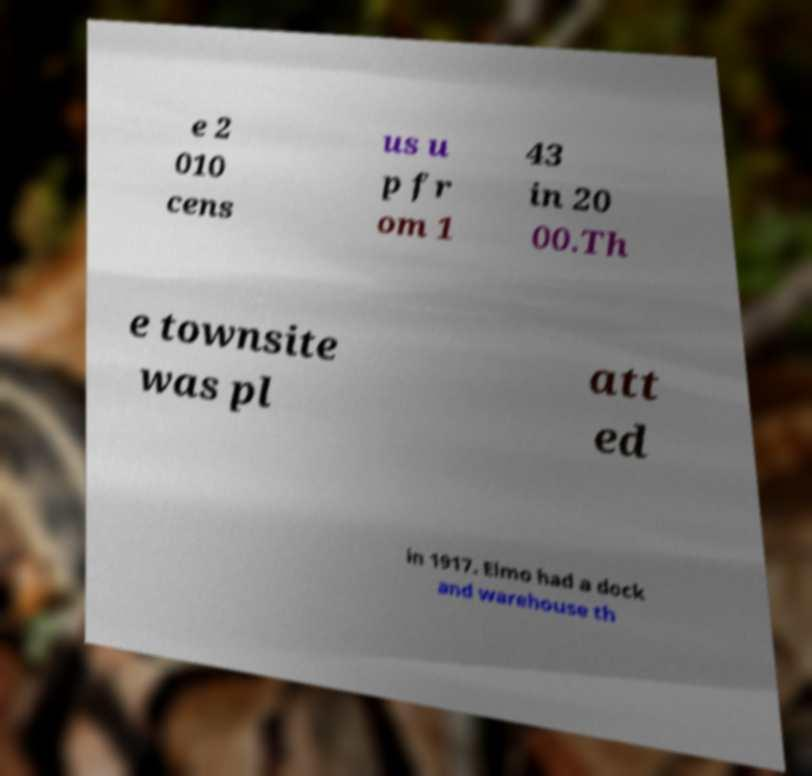There's text embedded in this image that I need extracted. Can you transcribe it verbatim? e 2 010 cens us u p fr om 1 43 in 20 00.Th e townsite was pl att ed in 1917. Elmo had a dock and warehouse th 